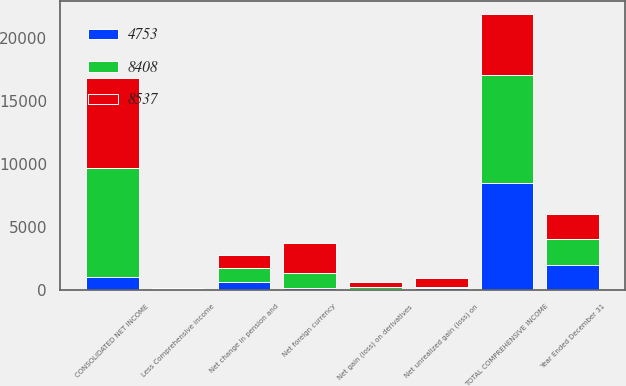<chart> <loc_0><loc_0><loc_500><loc_500><stacked_bar_chart><ecel><fcel>Year Ended December 31<fcel>CONSOLIDATED NET INCOME<fcel>Net foreign currency<fcel>Net gain (loss) on derivatives<fcel>Net unrealized gain (loss) on<fcel>Net change in pension and<fcel>TOTAL COMPREHENSIVE INCOME<fcel>Less Comprehensive income<nl><fcel>8537<fcel>2014<fcel>7124<fcel>2382<fcel>357<fcel>714<fcel>1039<fcel>4774<fcel>21<nl><fcel>8408<fcel>2013<fcel>8626<fcel>1187<fcel>151<fcel>80<fcel>1066<fcel>8576<fcel>39<nl><fcel>4753<fcel>2012<fcel>1039<fcel>182<fcel>99<fcel>178<fcel>668<fcel>8513<fcel>105<nl></chart> 